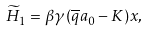Convert formula to latex. <formula><loc_0><loc_0><loc_500><loc_500>\widetilde { H } _ { 1 } = \beta \gamma { \left ( \overline { q } a _ { 0 } - K \right ) } x ,</formula> 